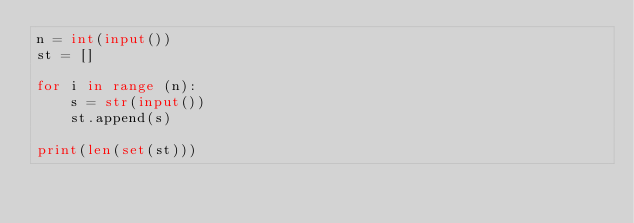Convert code to text. <code><loc_0><loc_0><loc_500><loc_500><_Python_>n = int(input())
st = []

for i in range (n):
    s = str(input())
    st.append(s)
  
print(len(set(st)))</code> 